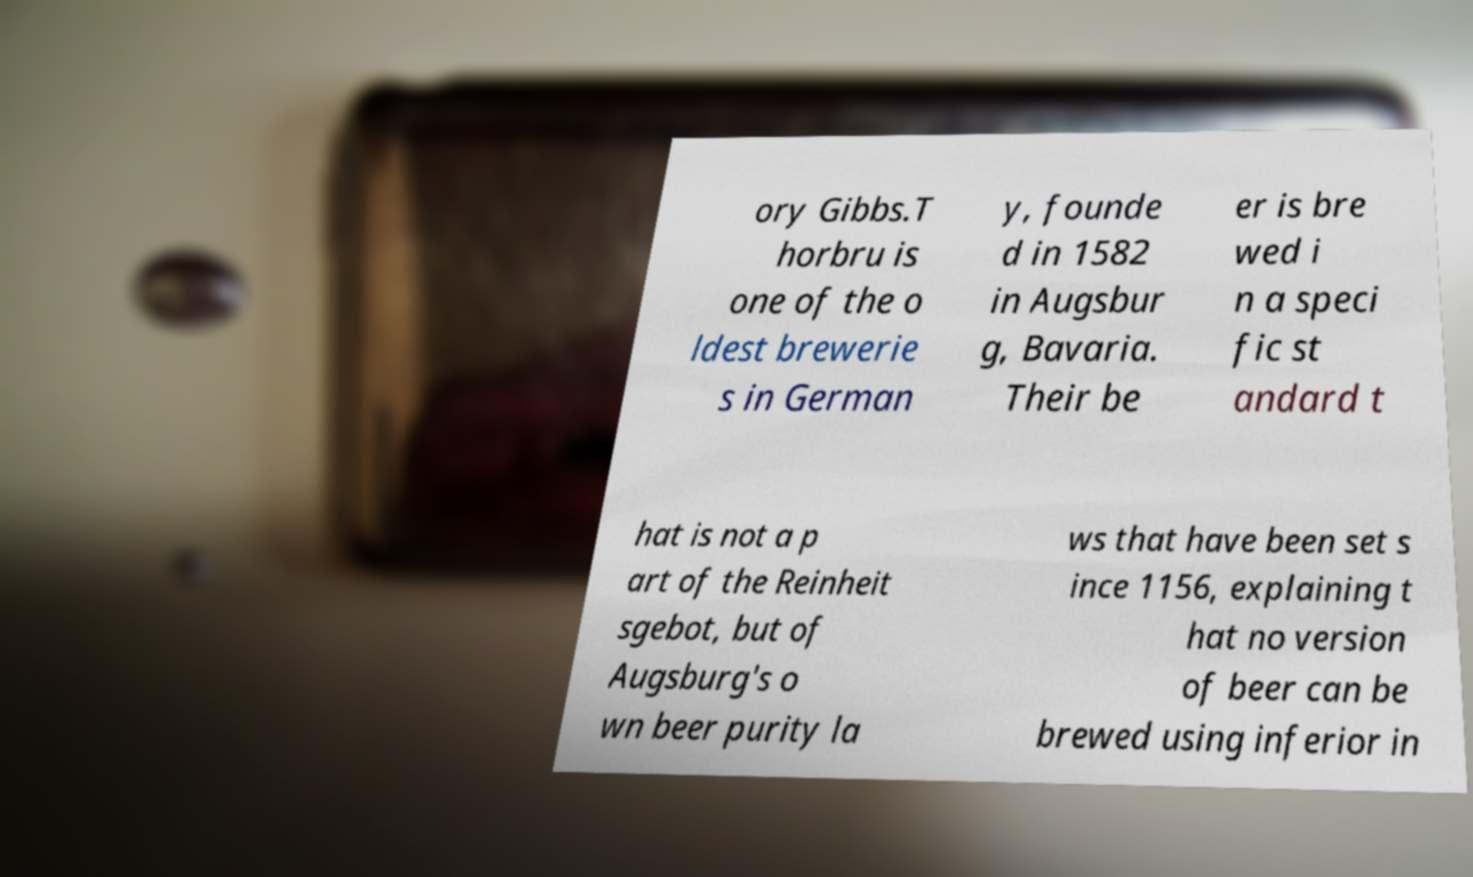Can you accurately transcribe the text from the provided image for me? ory Gibbs.T horbru is one of the o ldest brewerie s in German y, founde d in 1582 in Augsbur g, Bavaria. Their be er is bre wed i n a speci fic st andard t hat is not a p art of the Reinheit sgebot, but of Augsburg's o wn beer purity la ws that have been set s ince 1156, explaining t hat no version of beer can be brewed using inferior in 